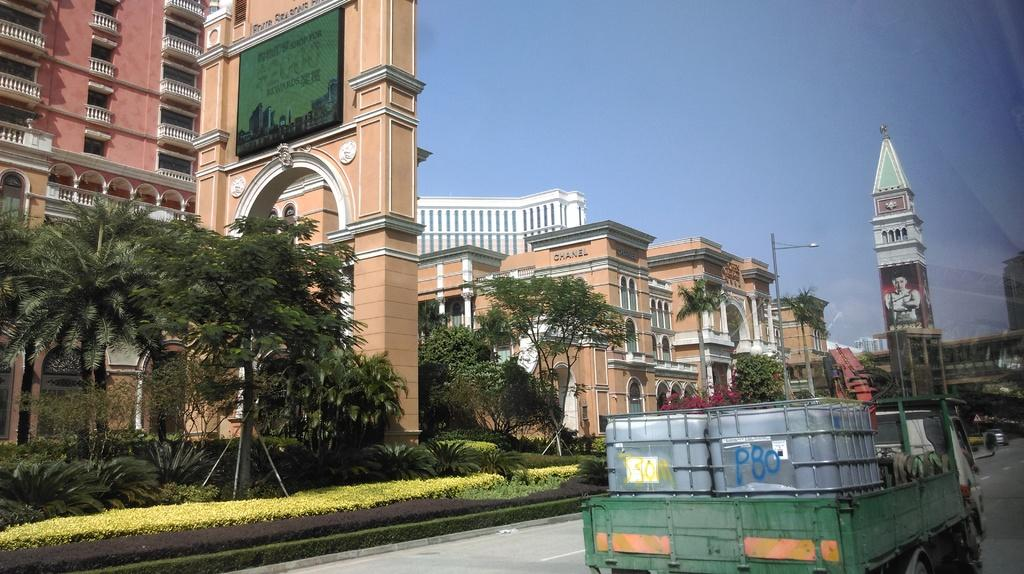What type of structures can be seen in the image? There are buildings in the image. What type of vegetation is present in the image? There are trees, bushes, and shrubs in the image. What type of urban infrastructure is visible in the image? There are street poles and street lights in the image. What is the tallest structure in the image? There is a tower in the image. What is visible in the sky in the image? The sky is visible in the image. What type of transportation is present on the road in the image? There is a motor vehicle on the road in the image. What type of juice is being served in the image? There is no juice present in the image. What type of skin condition can be seen on the people in the image? There are no people present in the image, so it is not possible to determine if anyone has a skin condition. 